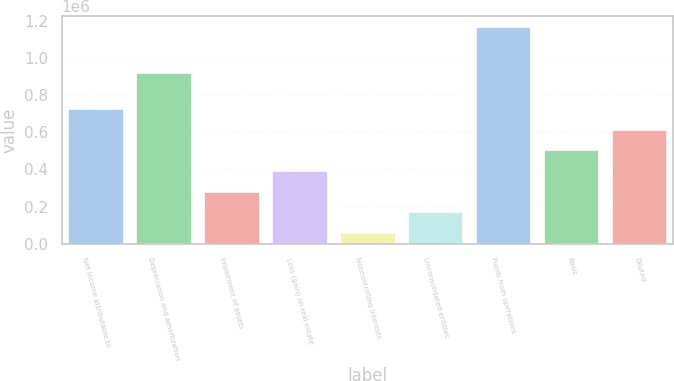<chart> <loc_0><loc_0><loc_500><loc_500><bar_chart><fcel>Net income attributable to<fcel>Depreciation and amortization<fcel>Impairment of assets<fcel>Loss (gain) on real estate<fcel>Noncontrolling interests<fcel>Unconsolidated entities<fcel>Funds from operations<fcel>Basic<fcel>Diluted<nl><fcel>723353<fcel>921720<fcel>281130<fcel>391685<fcel>60018<fcel>170574<fcel>1.16558e+06<fcel>502241<fcel>612797<nl></chart> 